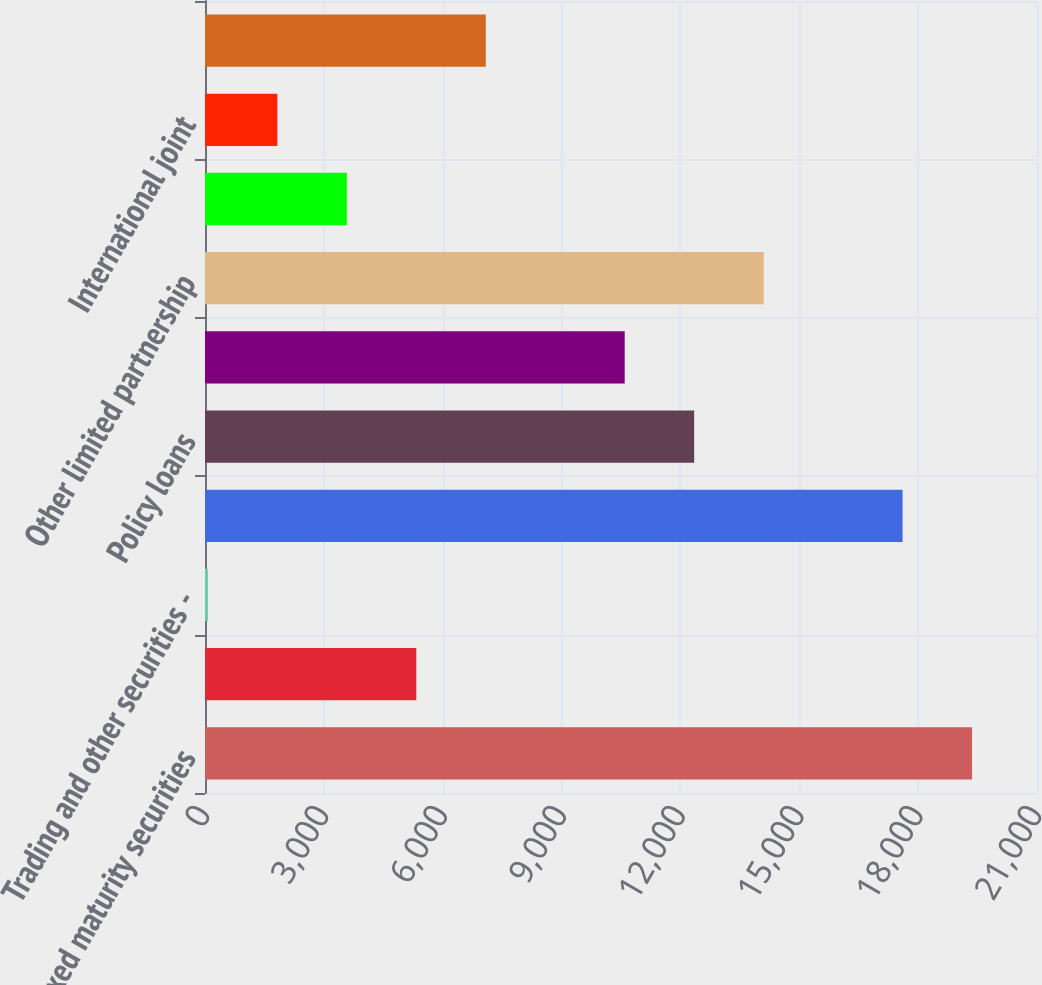<chart> <loc_0><loc_0><loc_500><loc_500><bar_chart><fcel>Fixed maturity securities<fcel>Equity securities<fcel>Trading and other securities -<fcel>Mortgage loans<fcel>Policy loans<fcel>Real estate and real estate<fcel>Other limited partnership<fcel>Cash cash equivalents and<fcel>International joint<fcel>Other<nl><fcel>19360.4<fcel>5333.2<fcel>73<fcel>17607<fcel>12346.8<fcel>10593.4<fcel>14100.2<fcel>3579.8<fcel>1826.4<fcel>7086.6<nl></chart> 